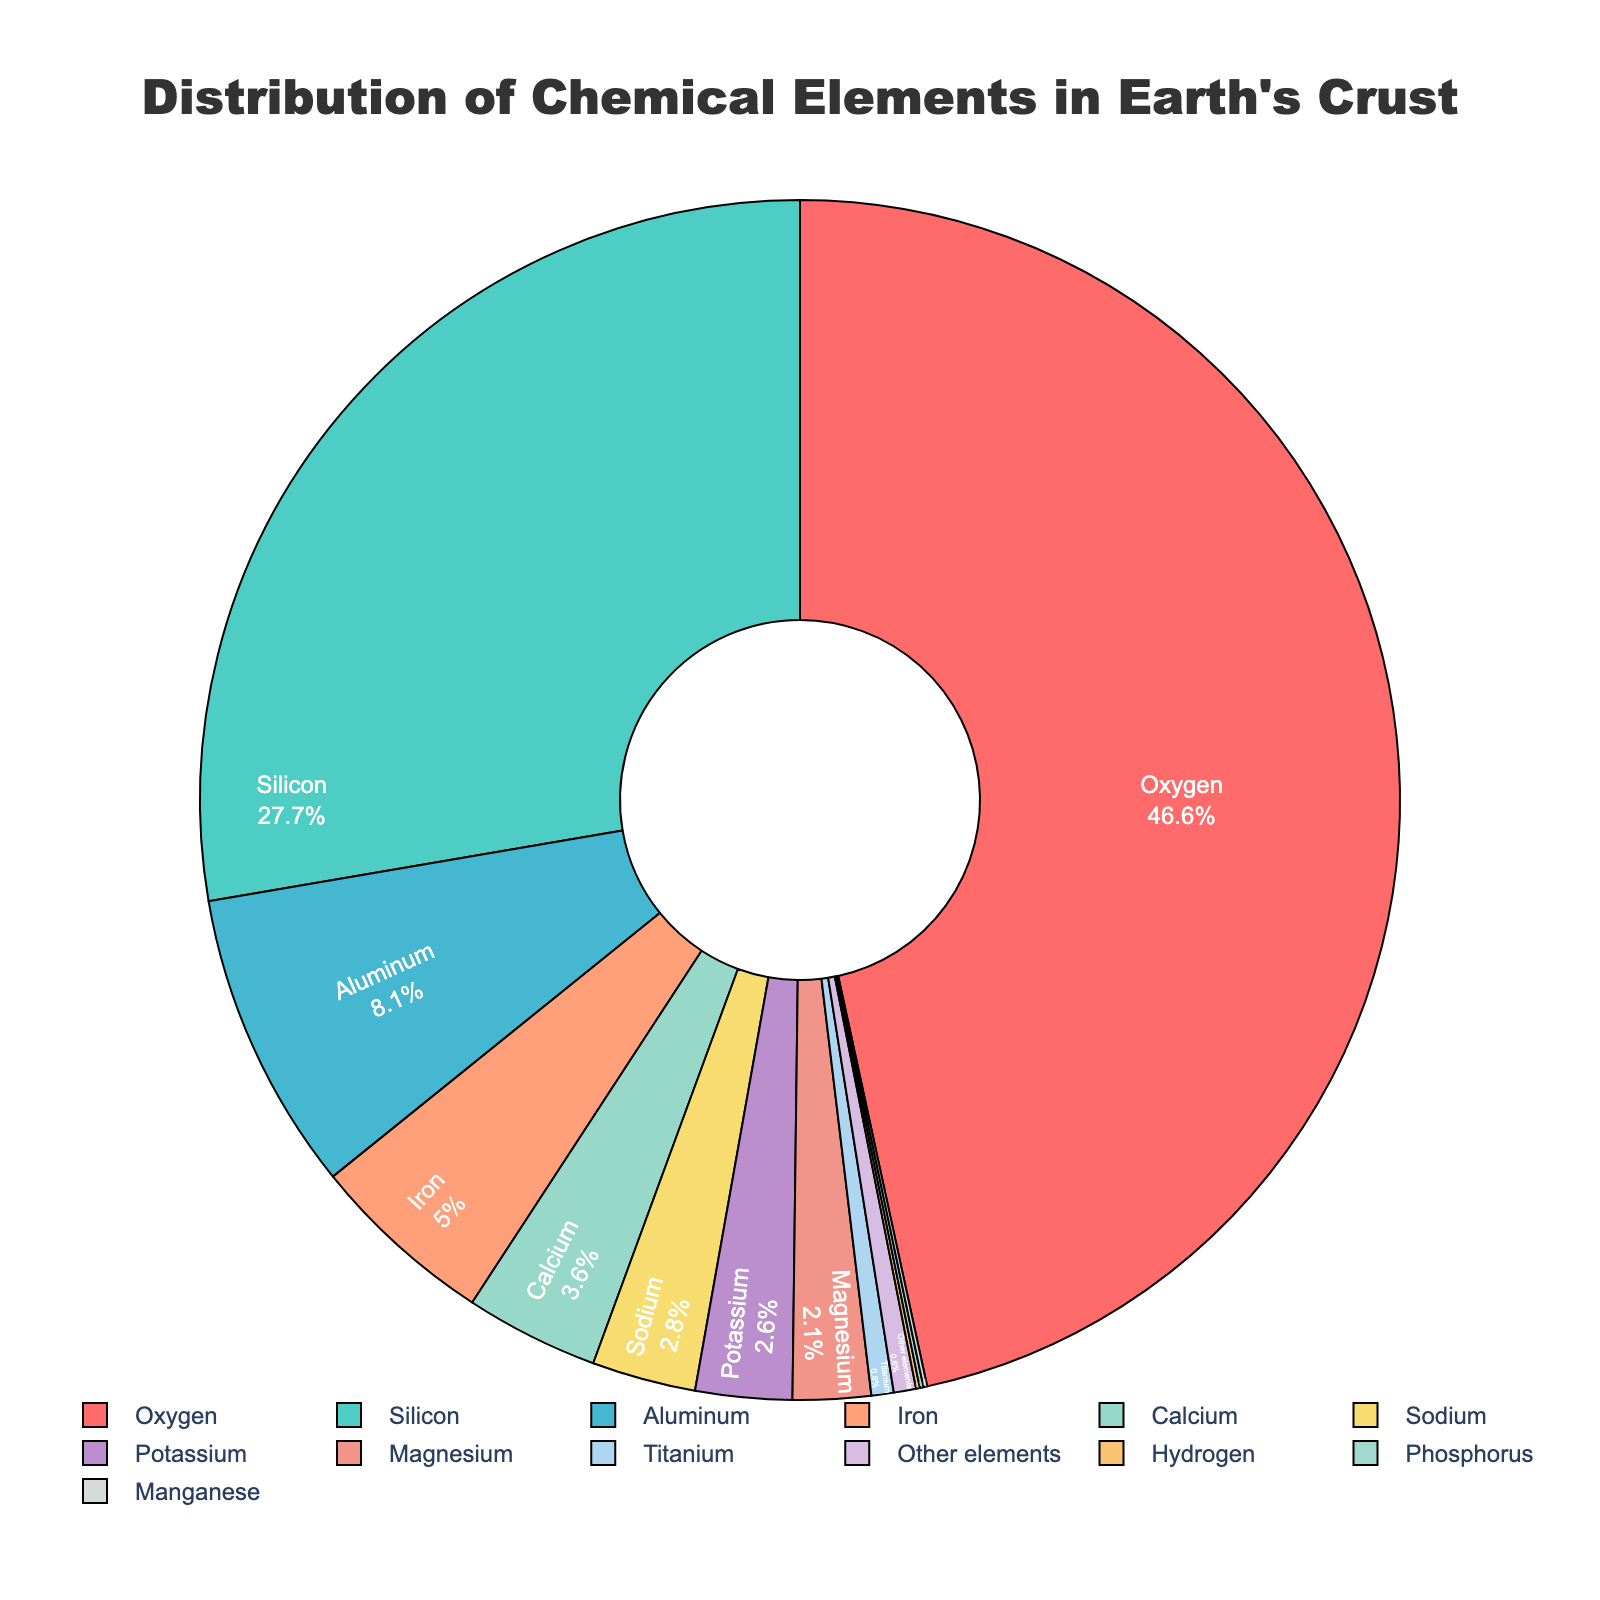Which element has the highest percentage in the Earth's crust? The pie chart shows that Oxygen has the largest segment in the chart. By looking at the labels and percentages, Oxygen is at the top with 46.6%.
Answer: Oxygen What is the combined percentage of Silicon and Aluminum in the Earth's crust? We look at the chart and find the percentages for Silicon (27.7%) and Aluminum (8.1%). Adding these together: 27.7 + 8.1 = 35.8%.
Answer: 35.8% Which element has a smaller percentage in the Earth's crust: Iron or Calcium? Comparing the sizes of the segments for Iron and Calcium in the pie chart, Iron is labeled 5.0% and Calcium is labeled 3.6%. 3.6% is smaller than 5.0%.
Answer: Calcium Are there any elements in the chart that contribute an equal percentage? Inspecting the labels on the pie chart, we see that Hydrogen, Phosphorus, and Manganese each contribute 0.1%.
Answer: Yes Which two elements together make up approximately 5% of the Earth's crust? Reviewing the chart, we find that Magnesium is 2.1% and Sodium is 2.8%. Adding their contributions: 2.1 + 2.8 = 4.9%, which is approximately 5%.
Answer: Magnesium and Sodium What color is the segment representing Potassium in the pie chart? Observing the visual representation of the chart, the segment for Potassium is distinguished by a specific color. In this case, it appears in light purple.
Answer: Light purple (or specify actual observed color) What is the difference in percentage between the two most abundant elements in the Earth's crust? Oxygen is 46.6% and Silicon is 27.7%. The difference is calculated by subtracting: 46.6 - 27.7 = 18.9%.
Answer: 18.9% What percentage of the Earth's crust is made up of elements other than Oxygen, Silicon, and Aluminum? Adding the percentages of Oxygen (46.6%), Silicon (27.7%), and Aluminum (8.1%) gives us 46.6 + 27.7 + 8.1 = 82.4%. Subtracting this from 100% (total): 100 - 82.4 = 17.6%.
Answer: 17.6% Which is more abundant in the Earth's crust: Sodium or Magnesium? By comparing the percentages in the pie chart, we see that Sodium is 2.8% and Magnesium is 2.1%. Sodium has a higher percentage.
Answer: Sodium 